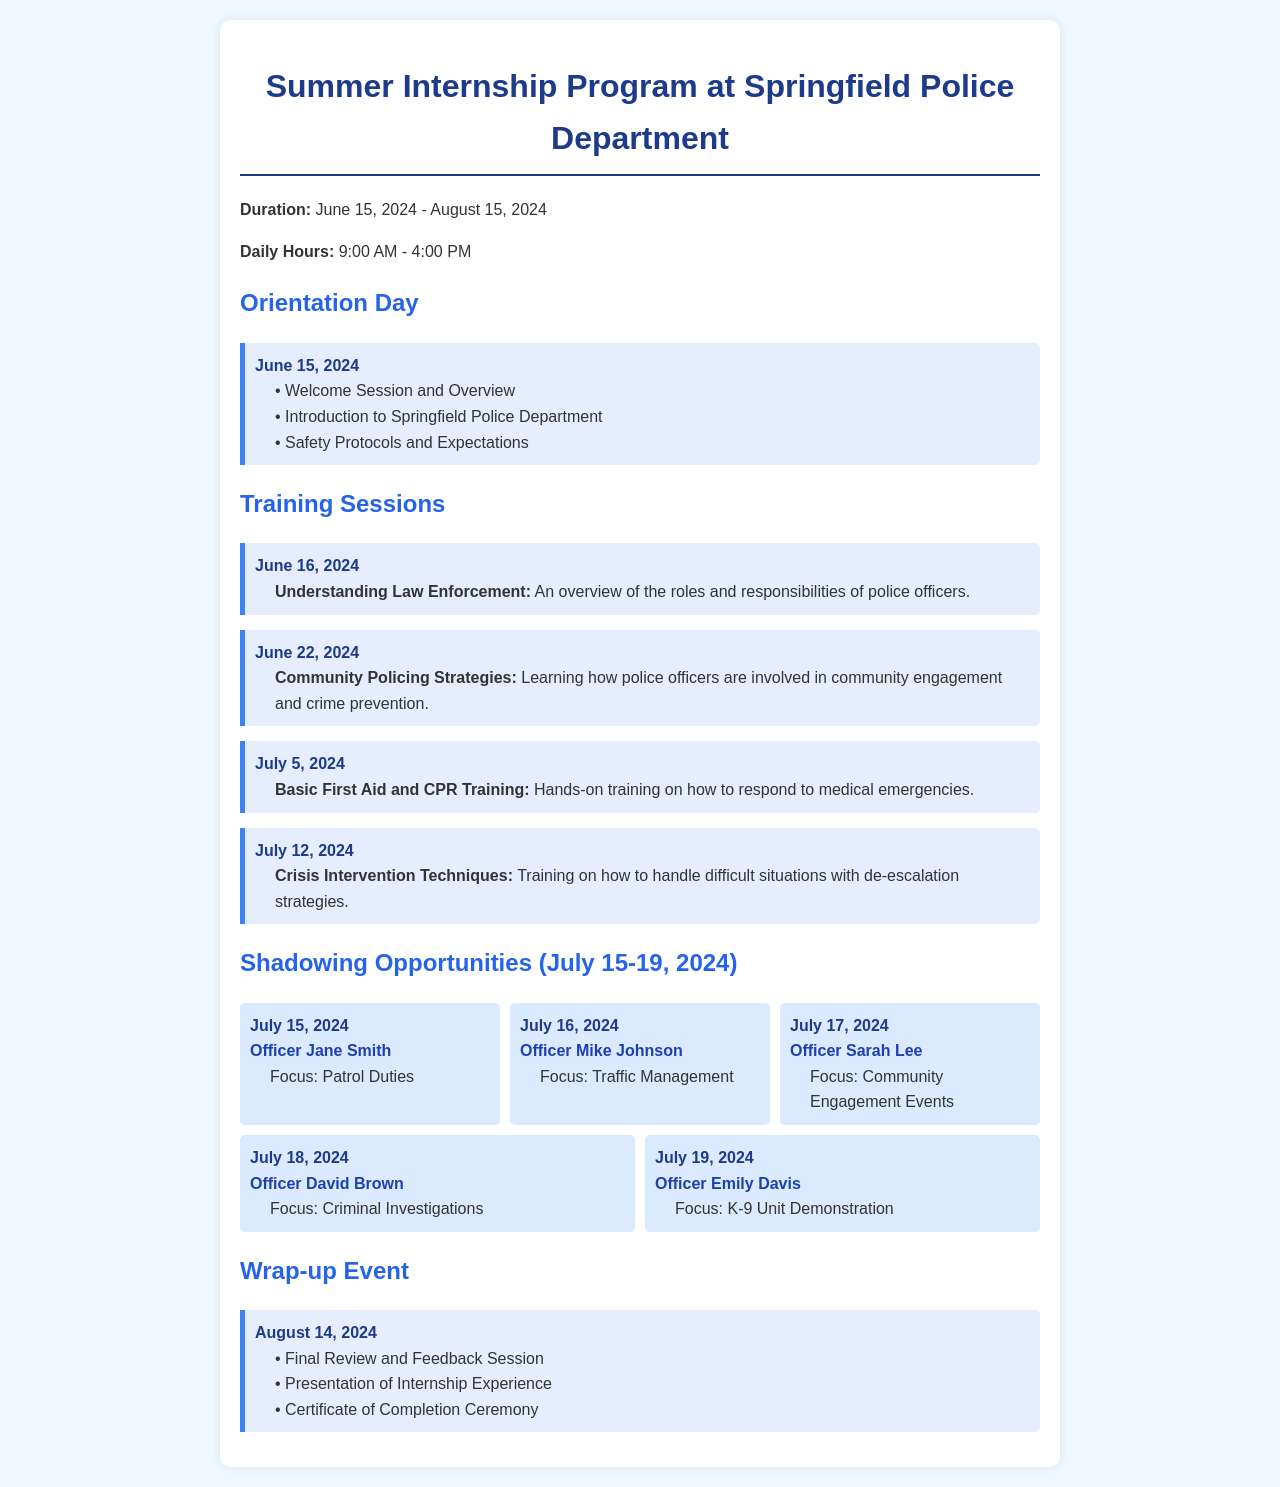What is the duration of the internship? The duration is indicated at the top of the document, providing the start and end dates of the internship program.
Answer: June 15, 2024 - August 15, 2024 What is the start date of the orientation? The orientation date is clearly listed under the Orientation Day section, specifying when it occurs.
Answer: June 15, 2024 Who leads the community engagement activities on July 17? The document names the officer responsible for community engagement activities on that specific date under the shadowing section.
Answer: Officer Sarah Lee Which training session focuses on crisis de-escalation? This information can be found in the training sessions section, detailing the content of each session.
Answer: Crisis Intervention Techniques What activity occurs on the final wrap-up event? The wrap-up event section outlines the activities that will take place during the event.
Answer: Certificate of Completion Ceremony Which officer is associated with the K-9 Unit demonstration? The officer linked to this specific shadowing opportunity is mentioned in the corresponding section.
Answer: Officer Emily Davis How many days of shadowing opportunities are there? To find this, count the individual shadowing opportunities listed in the document.
Answer: Five days What is the overall starting time for daily hours? The starting time for daily hours is mentioned clearly in the document.
Answer: 9:00 AM 